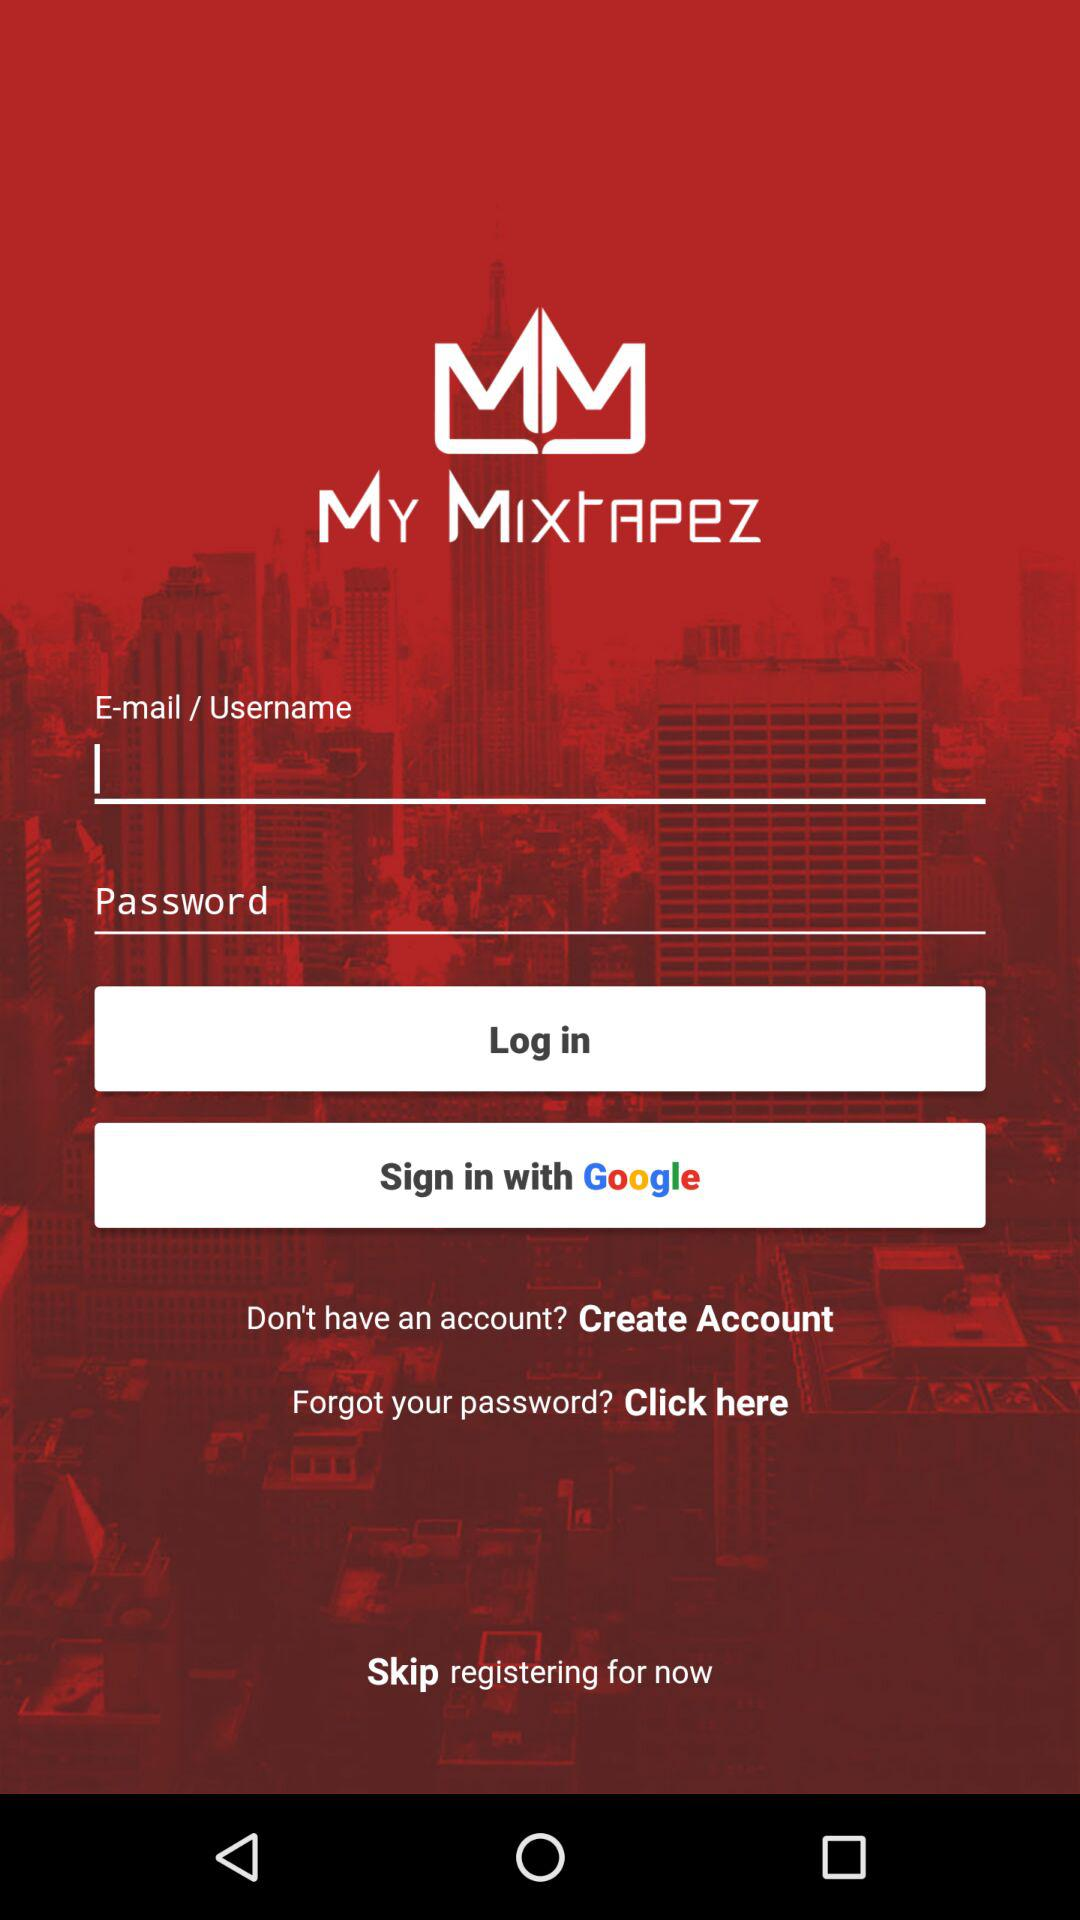How many fields are required to sign in?
Answer the question using a single word or phrase. 2 